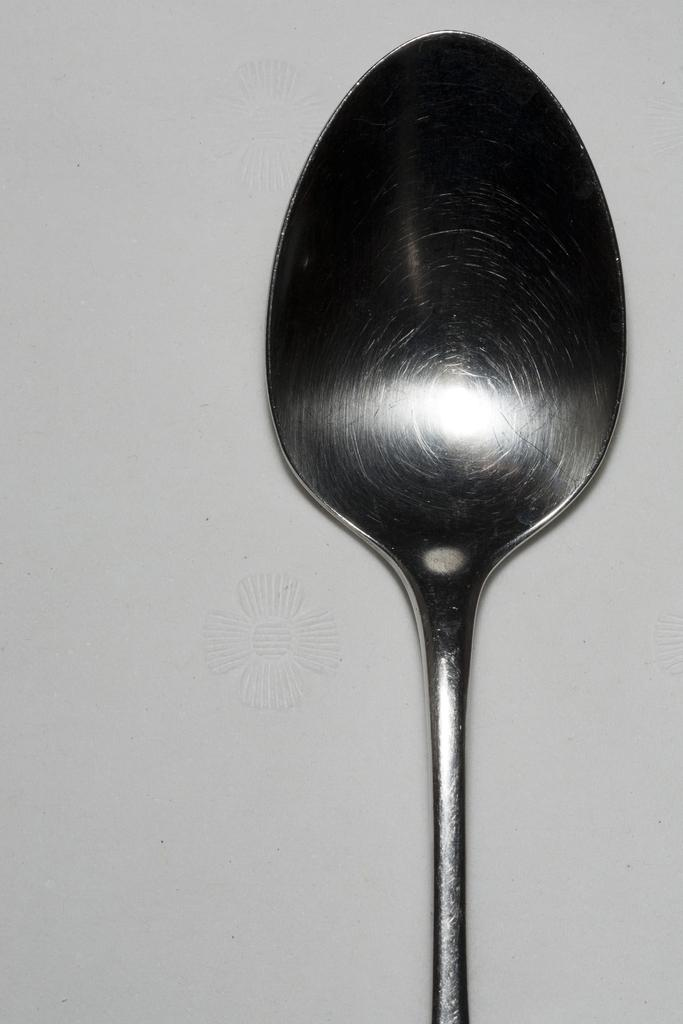What object can be seen in the image? There is a spoon in the image. Where is the spoon located in the image? The spoon is placed on a surface. What type of goat can be seen in the image? There is no goat present in the image; it only features a spoon placed on a surface. 